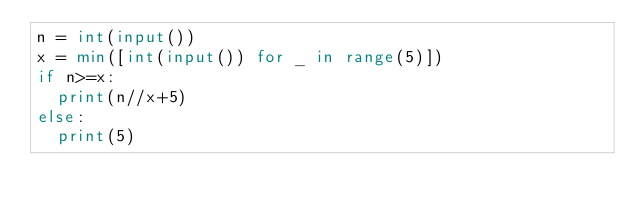Convert code to text. <code><loc_0><loc_0><loc_500><loc_500><_Python_>n = int(input())
x = min([int(input()) for _ in range(5)])
if n>=x:
  print(n//x+5)
else:
  print(5)</code> 